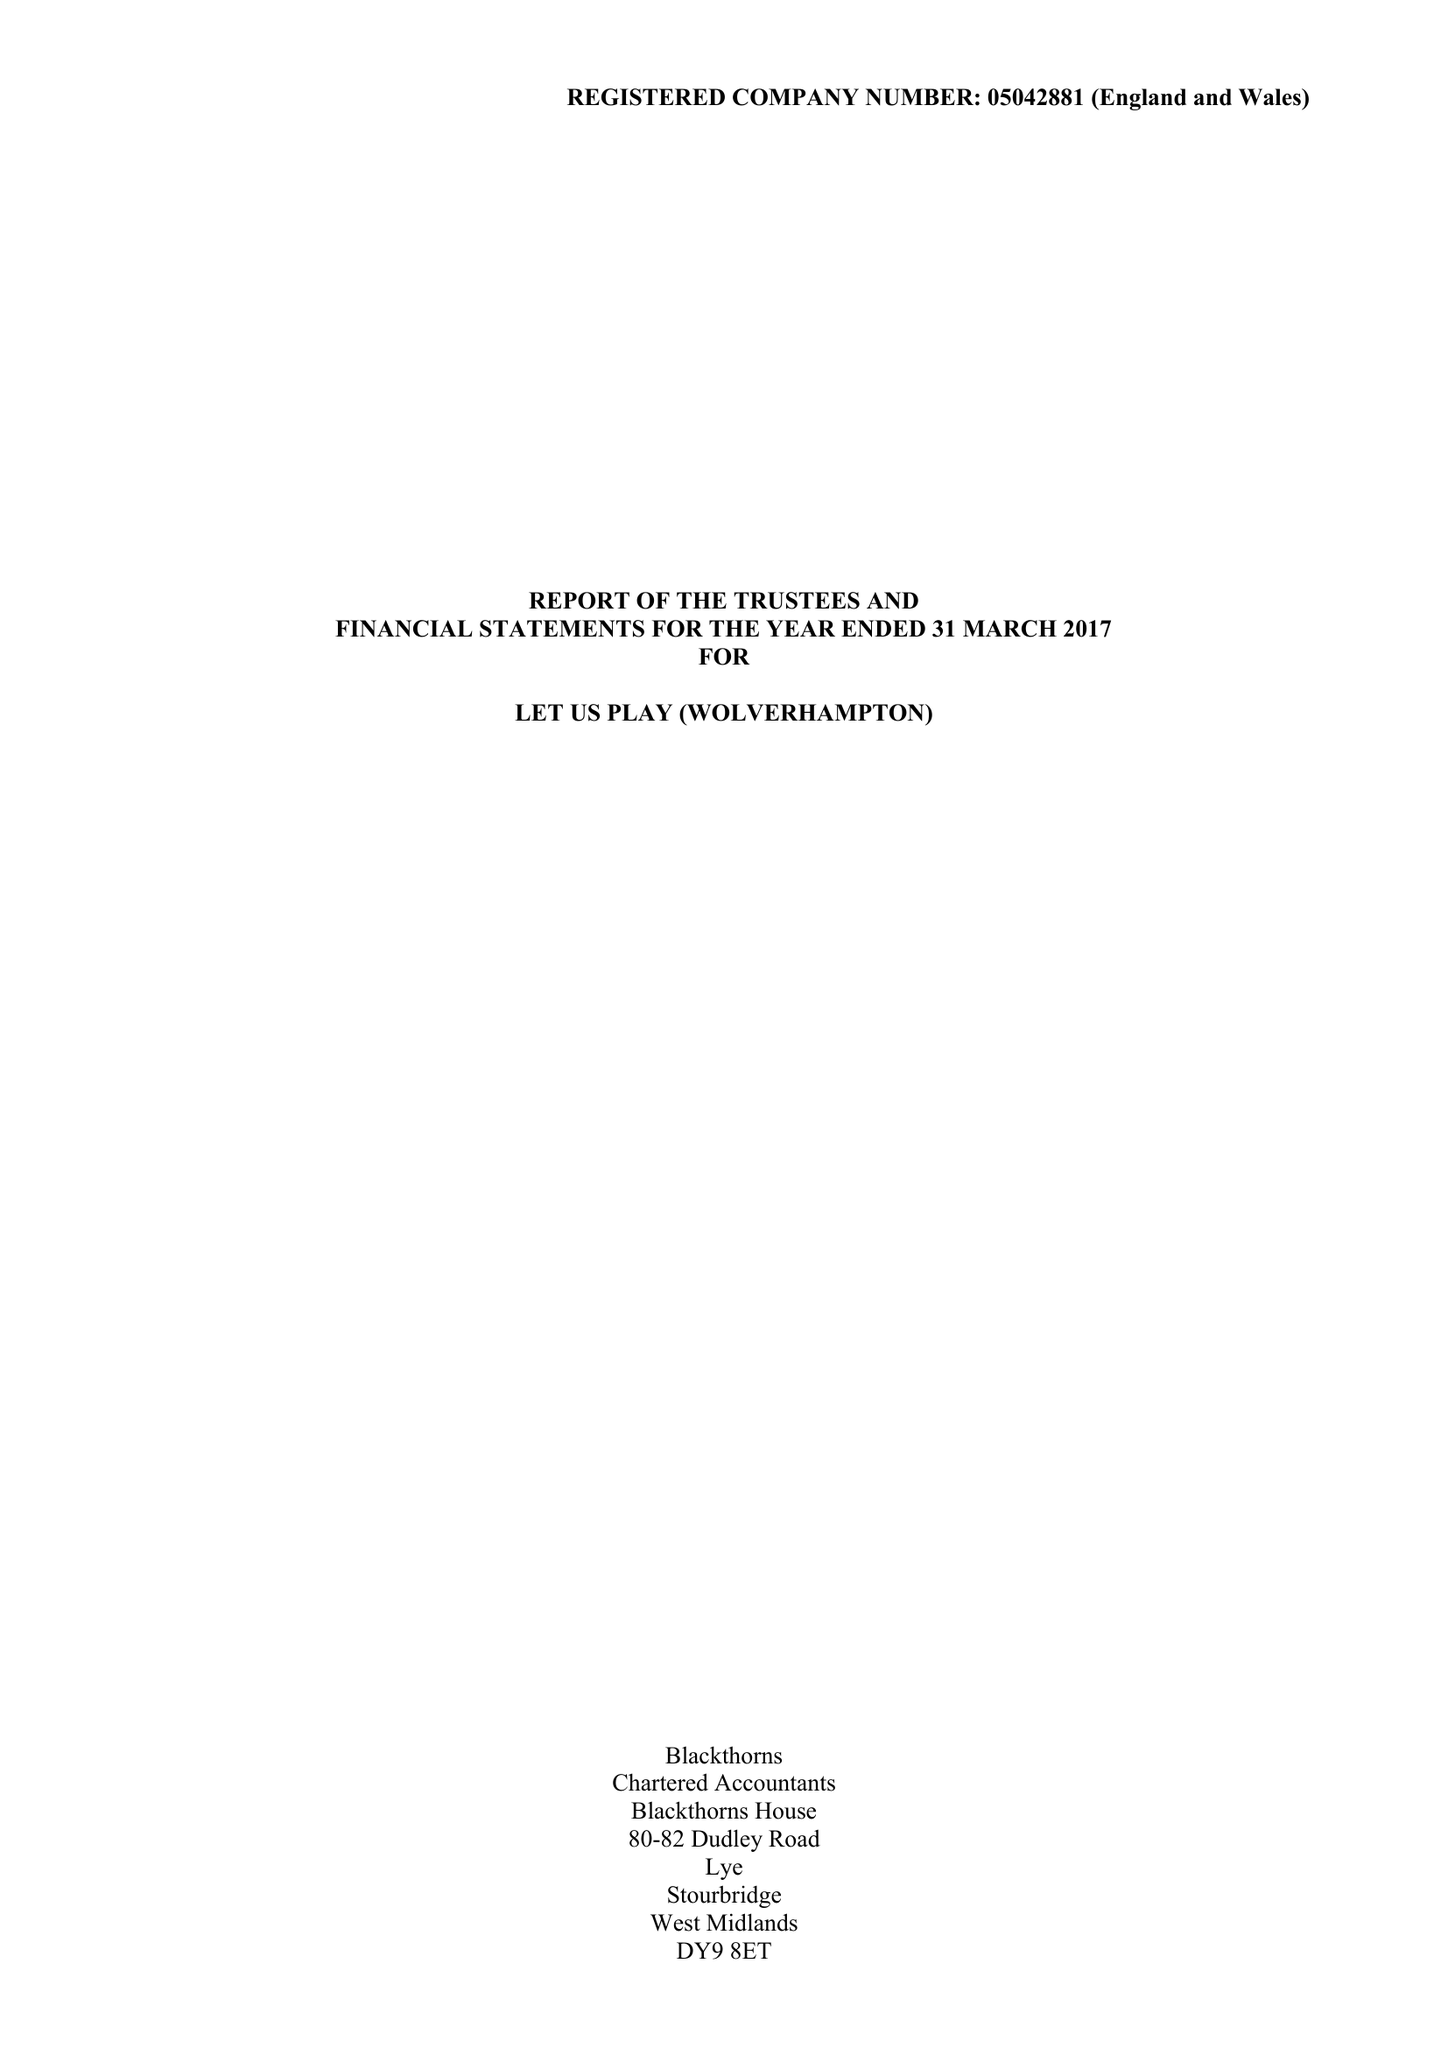What is the value for the charity_name?
Answer the question using a single word or phrase. Let Us Play (Wolverhampton) 